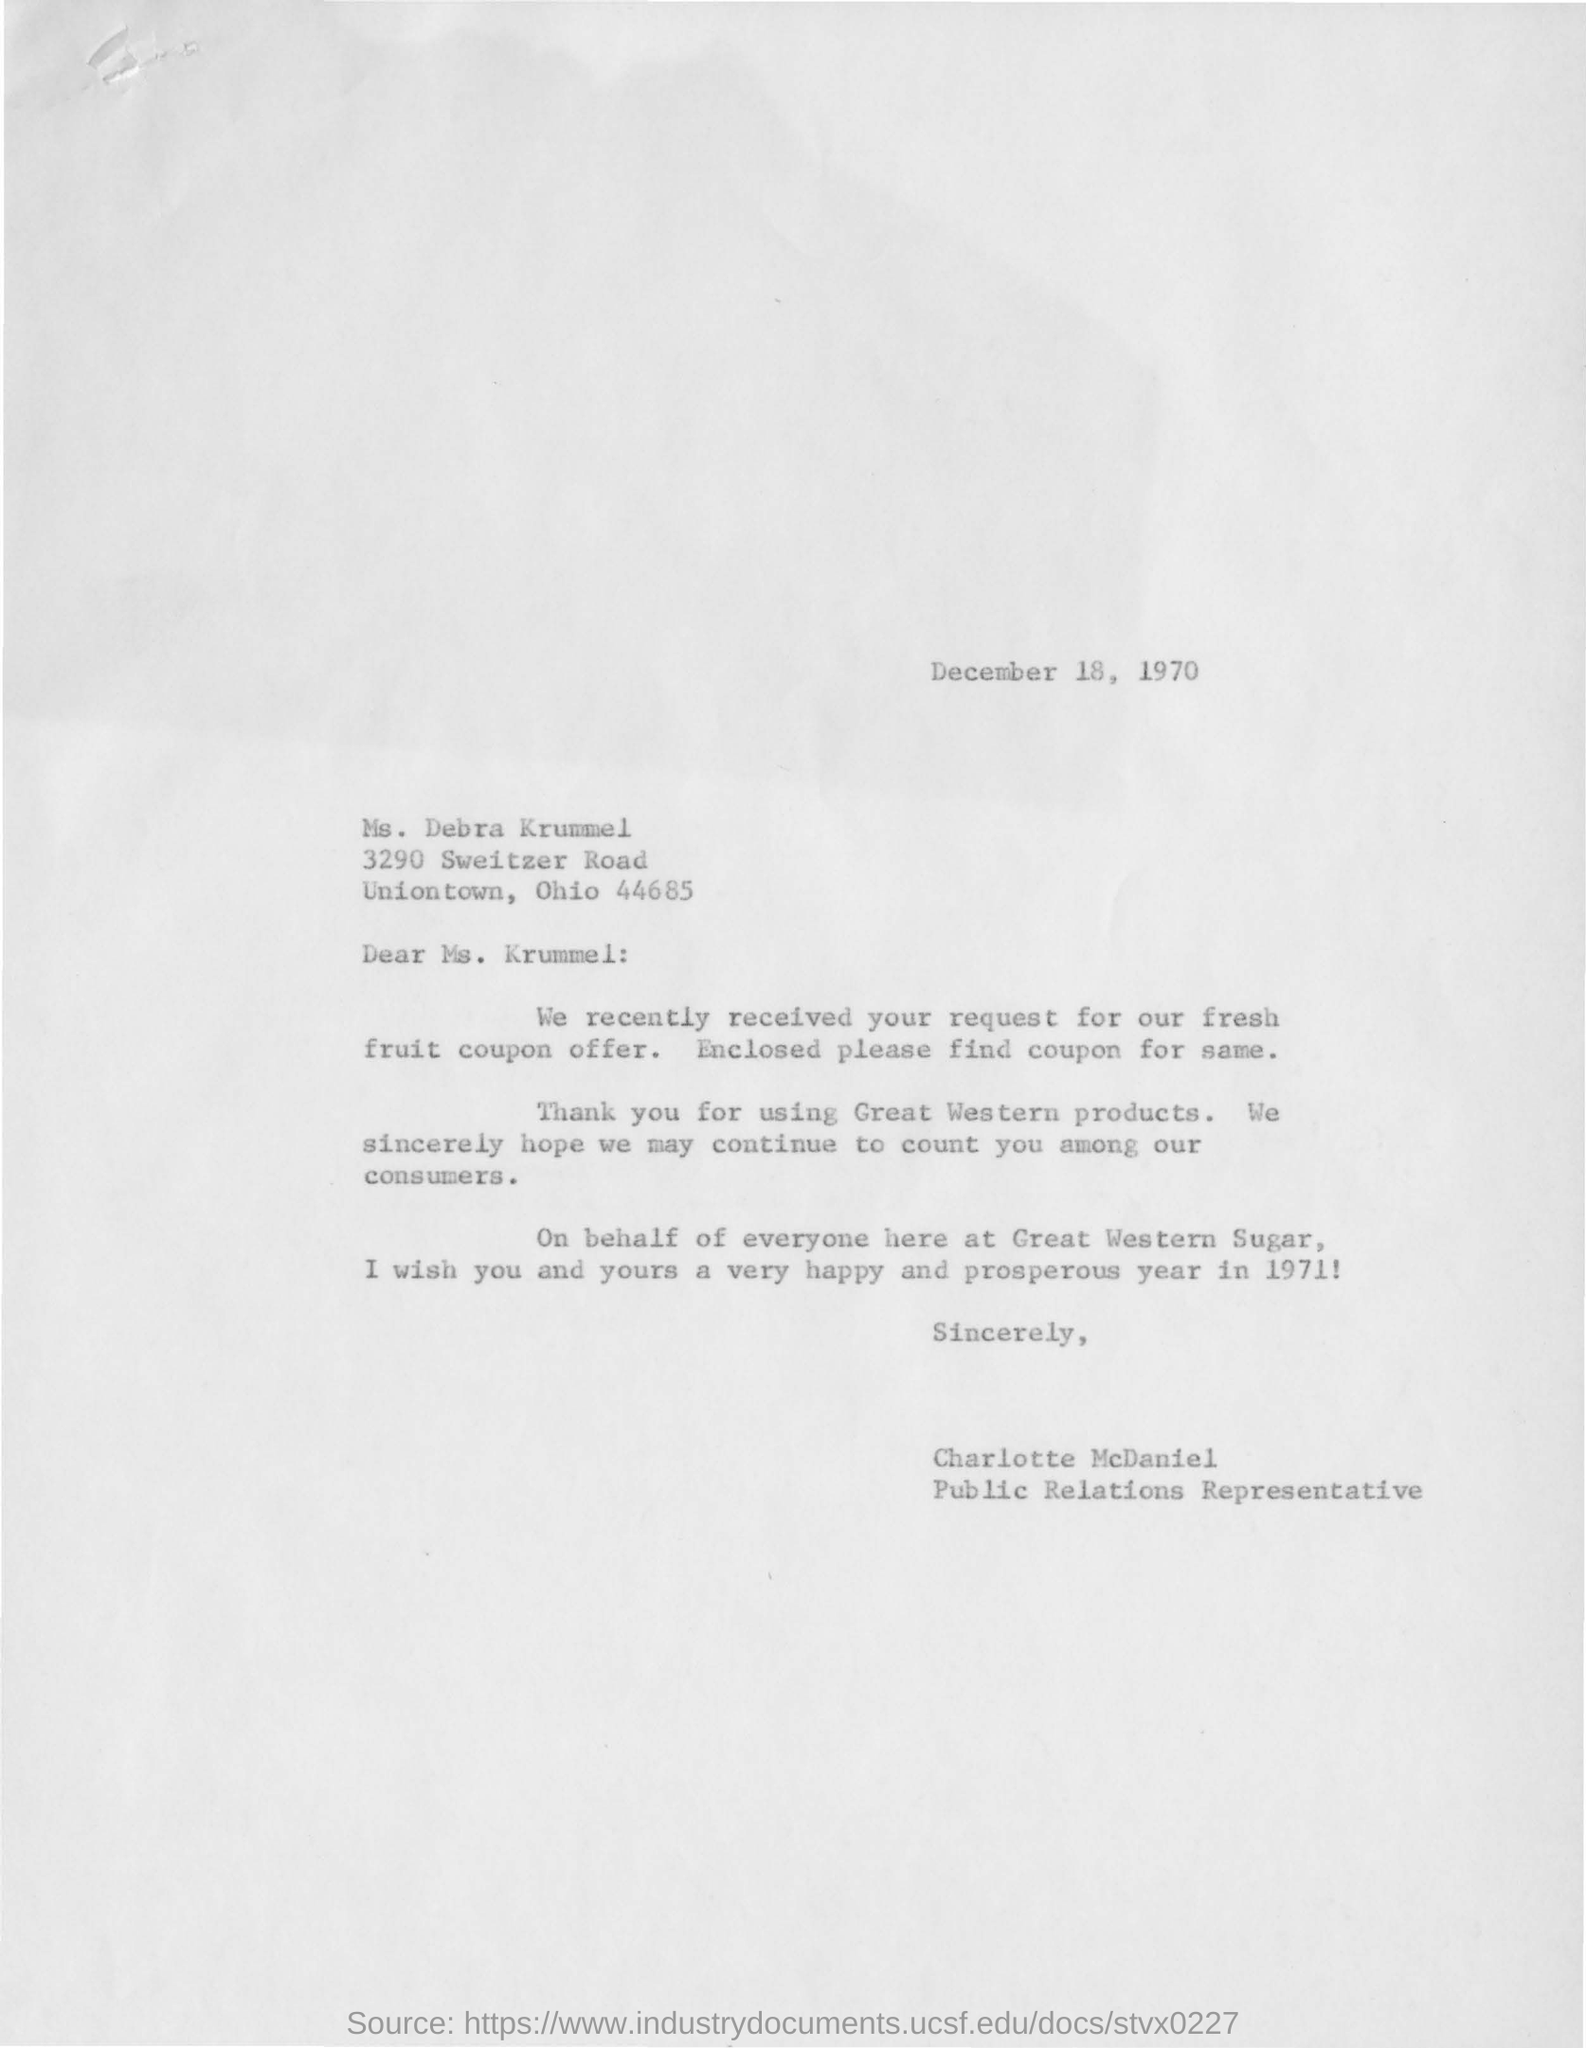Point out several critical features in this image. The letter contains a request for the Fresh Fruit Coupon Offer. Charlotte McDaniel is the public relations representative. The letter is addressed to Ms. Debra Krummel. This letter was written on December 18, 1970. Great Western's products are mentioned in the company. 